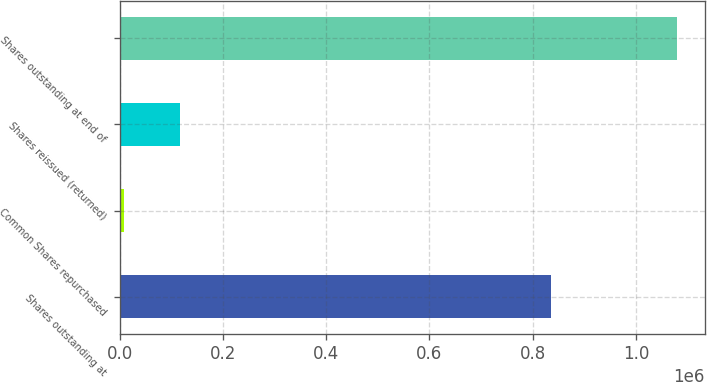<chart> <loc_0><loc_0><loc_500><loc_500><bar_chart><fcel>Shares outstanding at<fcel>Common Shares repurchased<fcel>Shares reissued (returned)<fcel>Shares outstanding at end of<nl><fcel>835751<fcel>9620<fcel>116589<fcel>1.07931e+06<nl></chart> 